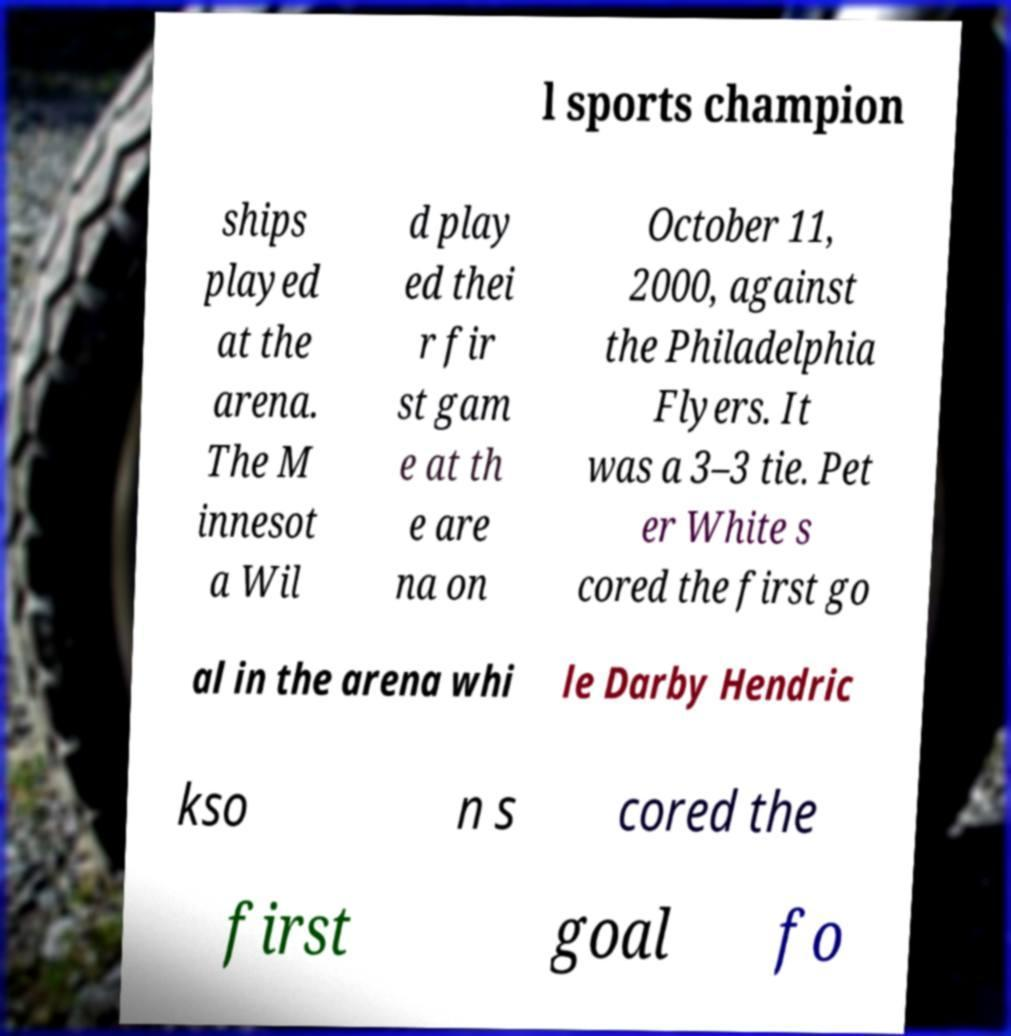What messages or text are displayed in this image? I need them in a readable, typed format. l sports champion ships played at the arena. The M innesot a Wil d play ed thei r fir st gam e at th e are na on October 11, 2000, against the Philadelphia Flyers. It was a 3–3 tie. Pet er White s cored the first go al in the arena whi le Darby Hendric kso n s cored the first goal fo 